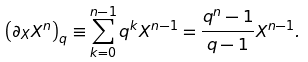Convert formula to latex. <formula><loc_0><loc_0><loc_500><loc_500>\left ( \partial _ { X } X ^ { n } \right ) _ { q } \equiv \sum _ { k = 0 } ^ { n - 1 } q ^ { k } X ^ { n - 1 } = \frac { q ^ { n } - 1 } { q - 1 } X ^ { n - 1 } .</formula> 